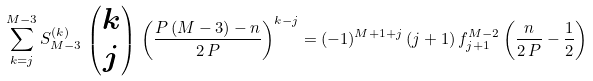<formula> <loc_0><loc_0><loc_500><loc_500>\sum _ { k = j } ^ { M - 3 } S _ { M - 3 } ^ { ( k ) } \, \begin{pmatrix} k \\ j \end{pmatrix} \, \left ( \frac { P \, ( M - 3 ) - n } { 2 \, P } \right ) ^ { k - j } = ( - 1 ) ^ { M + 1 + j } \, ( j + 1 ) \, f _ { j + 1 } ^ { M - 2 } \left ( \frac { n } { 2 \, P } - \frac { 1 } { 2 } \right )</formula> 